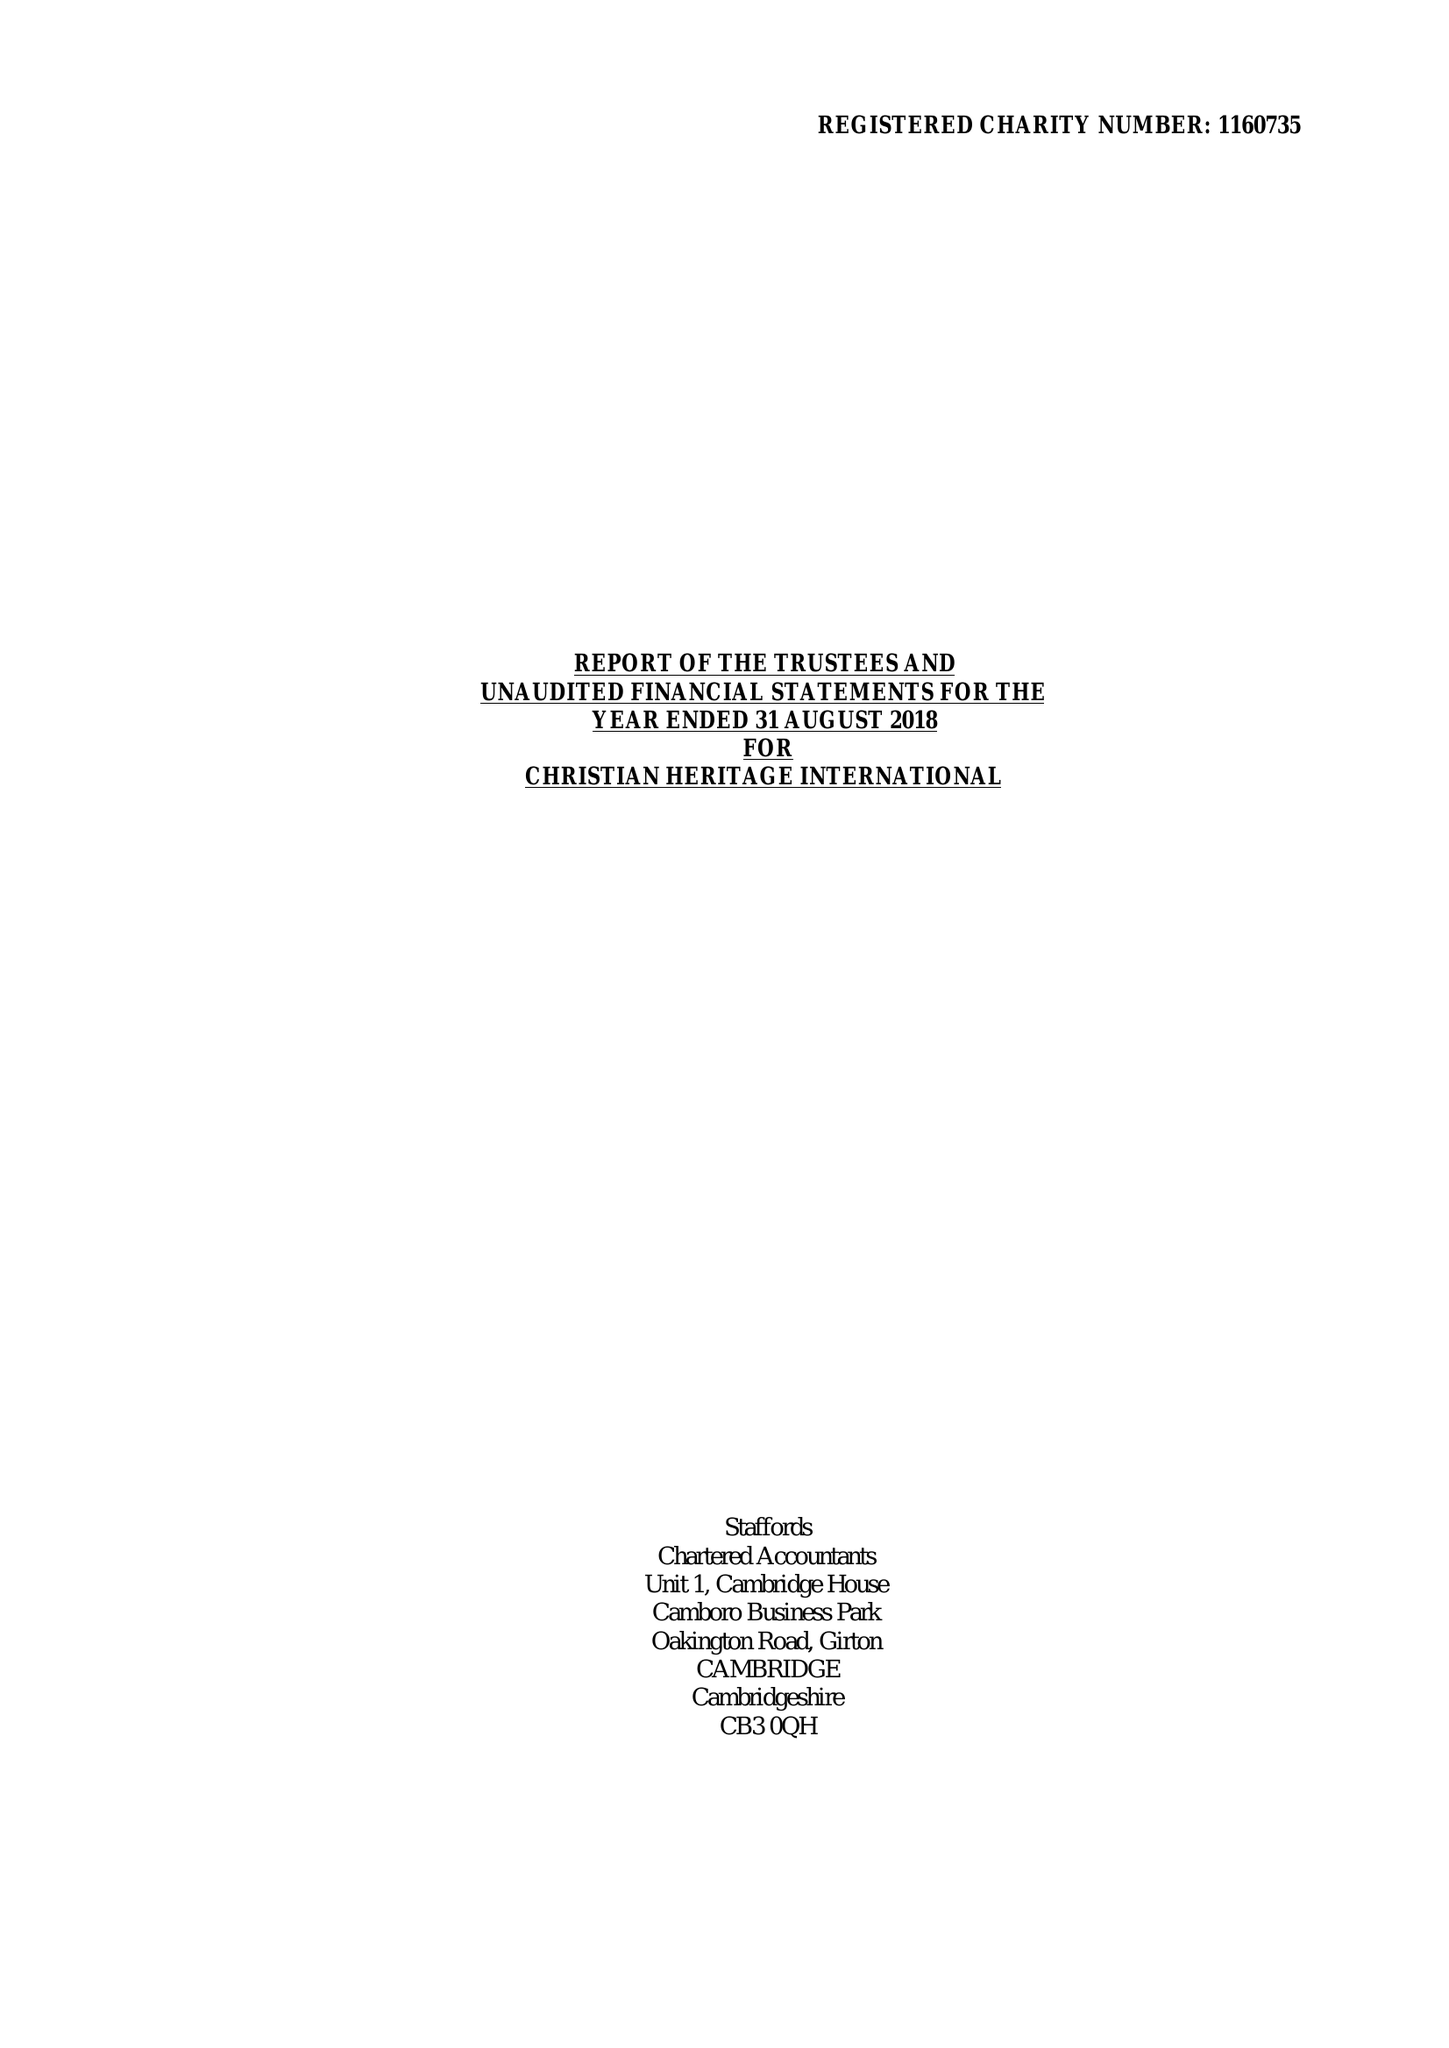What is the value for the address__street_line?
Answer the question using a single word or phrase. 46 THE GLEN 